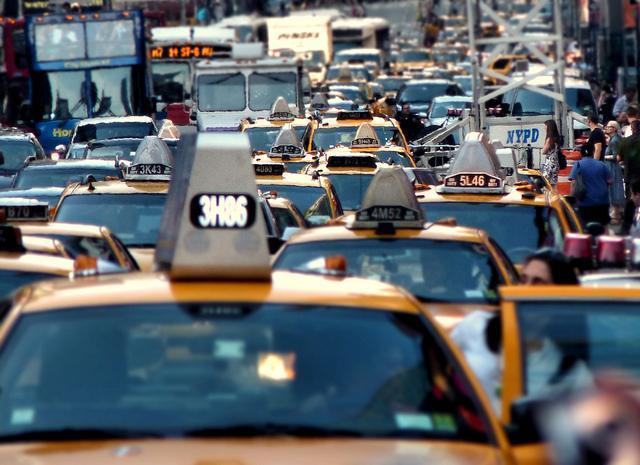How many people are in the photo?
Give a very brief answer. 2. How many trucks can be seen?
Give a very brief answer. 2. How many cars can you see?
Give a very brief answer. 10. How many buses are there?
Give a very brief answer. 3. How many chairs is this man sitting on?
Give a very brief answer. 0. 